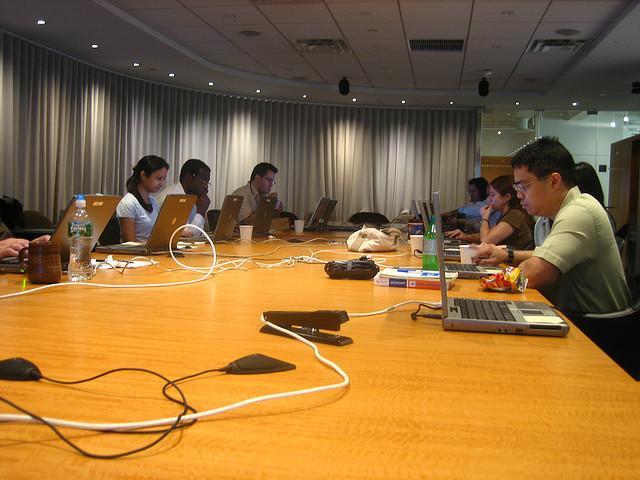Where are the people in? Please explain your reasoning. conference room. They are in a bigger room in a meeting. 